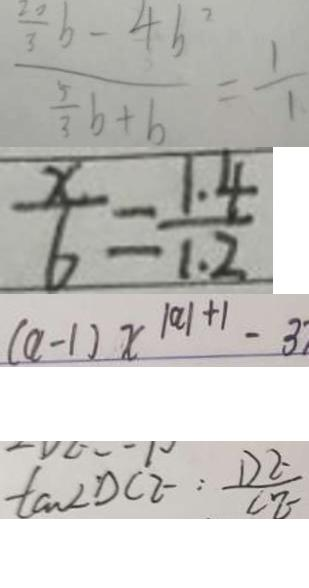Convert formula to latex. <formula><loc_0><loc_0><loc_500><loc_500>\frac { \frac { 2 0 } { 3 } b - 4 b ^ { 2 } } { \frac { 5 } { 3 } b + b } = \frac { 1 } { 1 } 
 \frac { x } { 6 } = \frac { 1 . 4 } { 1 . 2 } 
 ( a - 1 ) x ^ { \vert a \vert + 1 } - 3 
 \tan D C E : \frac { D E } { C E }</formula> 